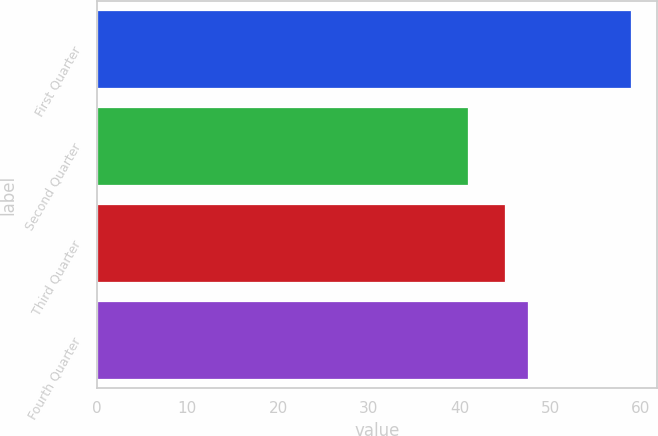<chart> <loc_0><loc_0><loc_500><loc_500><bar_chart><fcel>First Quarter<fcel>Second Quarter<fcel>Third Quarter<fcel>Fourth Quarter<nl><fcel>58.89<fcel>40.94<fcel>44.98<fcel>47.6<nl></chart> 